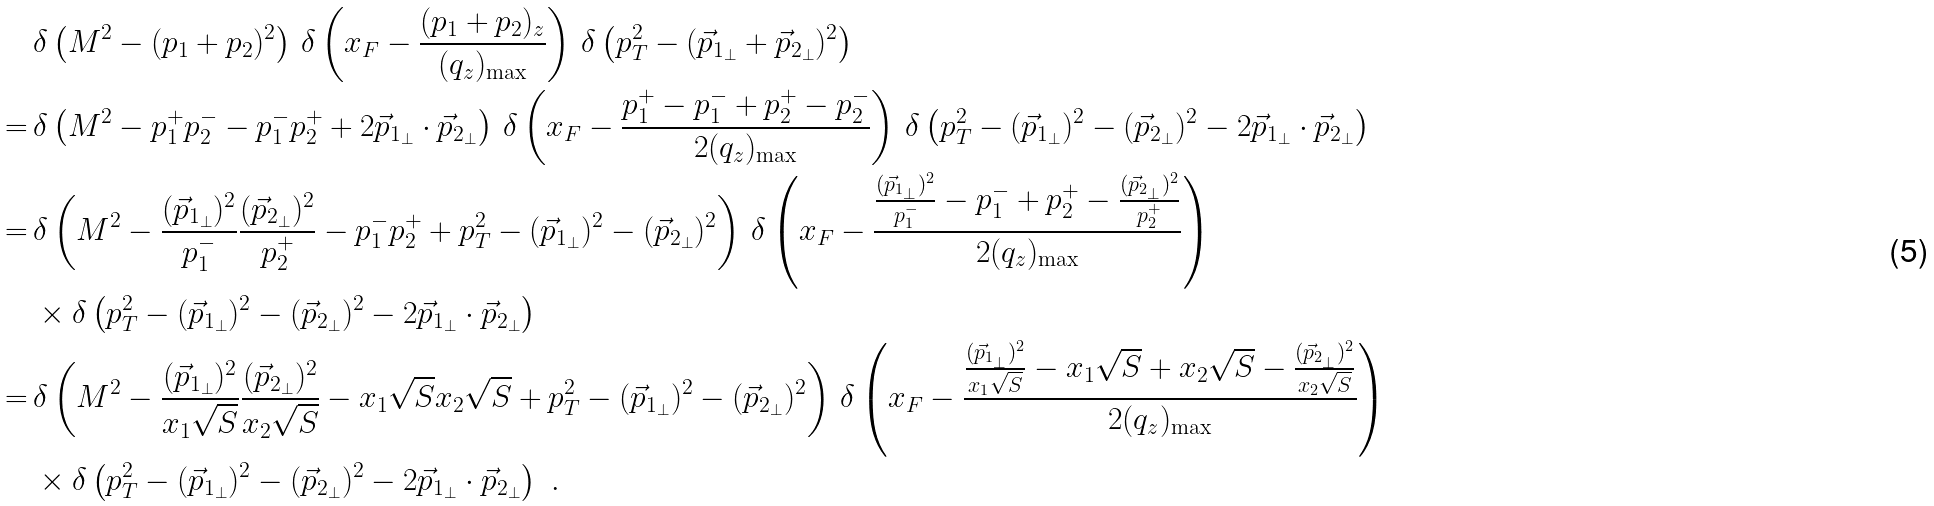<formula> <loc_0><loc_0><loc_500><loc_500>& \delta \left ( M ^ { 2 } - ( p _ { 1 } + p _ { 2 } ) ^ { 2 } \right ) \, \delta \left ( x _ { F } - \frac { ( p _ { 1 } + p _ { 2 } ) _ { z } } { ( q _ { z } ) _ { \max } } \right ) \, \delta \left ( p _ { T } ^ { 2 } - ( { \vec { p } } _ { 1 _ { \perp } } + { \vec { p } } _ { 2 _ { \perp } } ) ^ { 2 } \right ) \\ = \, & \delta \left ( M ^ { 2 } - p _ { 1 } ^ { + } p _ { 2 } ^ { - } - p _ { 1 } ^ { - } p _ { 2 } ^ { + } + 2 { \vec { p } } _ { 1 _ { \perp } } \cdot { \vec { p } } _ { 2 _ { \perp } } \right ) \, \delta \left ( x _ { F } - \frac { p _ { 1 } ^ { + } - p _ { 1 } ^ { - } + p _ { 2 } ^ { + } - p _ { 2 } ^ { - } } { 2 ( q _ { z } ) _ { \max } } \right ) \, \delta \left ( p _ { T } ^ { 2 } - ( { \vec { p } } _ { 1 _ { \perp } } ) ^ { 2 } - ( { \vec { p } } _ { 2 _ { \perp } } ) ^ { 2 } - 2 { \vec { p } } _ { 1 _ { \perp } } \cdot { \vec { p } } _ { 2 _ { \perp } } \right ) \\ = \, & \delta \left ( M ^ { 2 } - \frac { ( { \vec { p } } _ { 1 _ { \perp } } ) ^ { 2 } } { p _ { 1 } ^ { - } } \frac { ( { \vec { p } } _ { 2 _ { \perp } } ) ^ { 2 } } { p _ { 2 } ^ { + } } - p _ { 1 } ^ { - } p _ { 2 } ^ { + } + p _ { T } ^ { 2 } - ( { \vec { p } } _ { 1 _ { \perp } } ) ^ { 2 } - ( { \vec { p } } _ { 2 _ { \perp } } ) ^ { 2 } \right ) \, \delta \left ( x _ { F } - \frac { \frac { ( { \vec { p } } _ { 1 _ { \perp } } ) ^ { 2 } } { p _ { 1 } ^ { - } } - p _ { 1 } ^ { - } + p _ { 2 } ^ { + } - \frac { ( { \vec { p } } _ { 2 _ { \perp } } ) ^ { 2 } } { p _ { 2 } ^ { + } } } { 2 ( q _ { z } ) _ { \max } } \right ) \\ & \times \delta \left ( p _ { T } ^ { 2 } - ( { \vec { p } } _ { 1 _ { \perp } } ) ^ { 2 } - ( { \vec { p } } _ { 2 _ { \perp } } ) ^ { 2 } - 2 { \vec { p } } _ { 1 _ { \perp } } \cdot { \vec { p } } _ { 2 _ { \perp } } \right ) \\ = \, & \delta \left ( M ^ { 2 } - \frac { ( { \vec { p } } _ { 1 _ { \perp } } ) ^ { 2 } } { x _ { 1 } \sqrt { S } } \frac { ( { \vec { p } } _ { 2 _ { \perp } } ) ^ { 2 } } { x _ { 2 } \sqrt { S } } - x _ { 1 } \sqrt { S } x _ { 2 } \sqrt { S } + p _ { T } ^ { 2 } - ( { \vec { p } } _ { 1 _ { \perp } } ) ^ { 2 } - ( { \vec { p } } _ { 2 _ { \perp } } ) ^ { 2 } \right ) \, \delta \left ( x _ { F } - \frac { \frac { ( { \vec { p } } _ { 1 _ { \perp } } ) ^ { 2 } } { x _ { 1 } \sqrt { S } } - x _ { 1 } \sqrt { S } + x _ { 2 } \sqrt { S } - \frac { ( { \vec { p } } _ { 2 _ { \perp } } ) ^ { 2 } } { x _ { 2 } \sqrt { S } } } { 2 ( q _ { z } ) _ { \max } } \right ) \, \\ & \times \delta \left ( p _ { T } ^ { 2 } - ( { \vec { p } } _ { 1 _ { \perp } } ) ^ { 2 } - ( { \vec { p } } _ { 2 _ { \perp } } ) ^ { 2 } - 2 { \vec { p } } _ { 1 _ { \perp } } \cdot { \vec { p } } _ { 2 _ { \perp } } \right ) \ .</formula> 